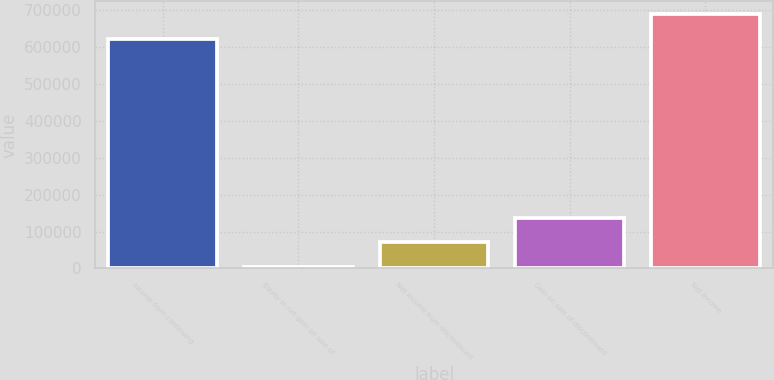Convert chart. <chart><loc_0><loc_0><loc_500><loc_500><bar_chart><fcel>Income from continuing<fcel>Equity in net gain on sale of<fcel>Net income from discontinued<fcel>Gain on sale of discontinued<fcel>Net income<nl><fcel>622477<fcel>2918<fcel>70338.4<fcel>137759<fcel>689897<nl></chart> 